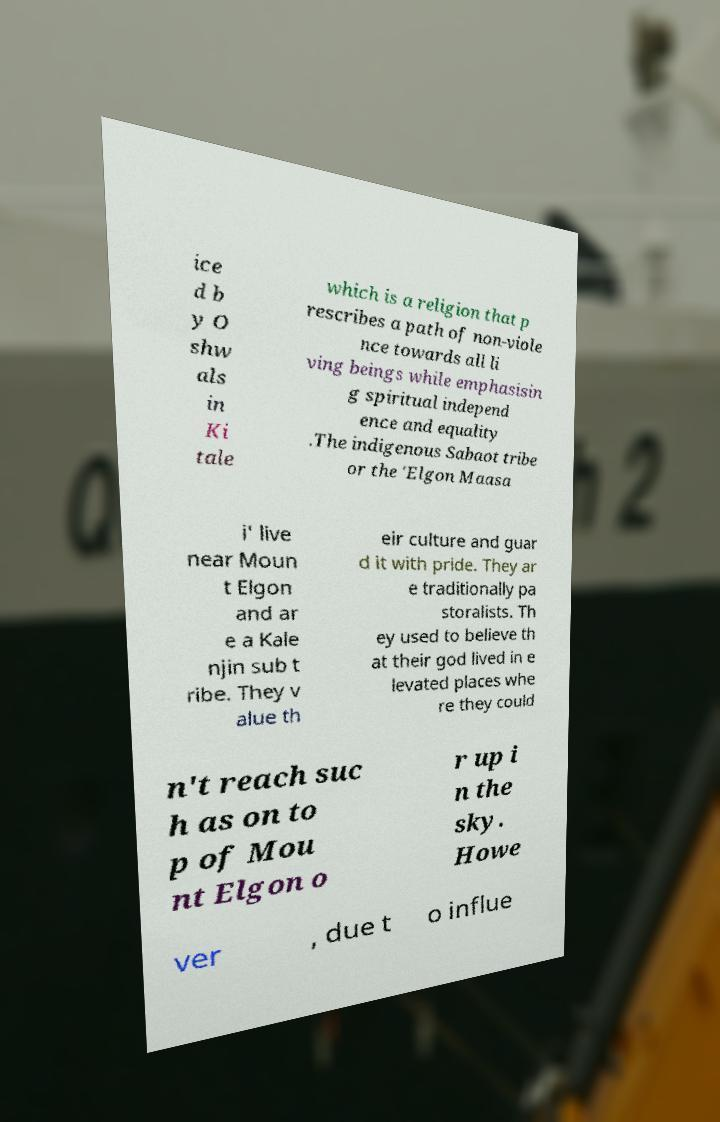Can you accurately transcribe the text from the provided image for me? ice d b y O shw als in Ki tale which is a religion that p rescribes a path of non-viole nce towards all li ving beings while emphasisin g spiritual independ ence and equality .The indigenous Sabaot tribe or the 'Elgon Maasa i' live near Moun t Elgon and ar e a Kale njin sub t ribe. They v alue th eir culture and guar d it with pride. They ar e traditionally pa storalists. Th ey used to believe th at their god lived in e levated places whe re they could n't reach suc h as on to p of Mou nt Elgon o r up i n the sky. Howe ver , due t o influe 